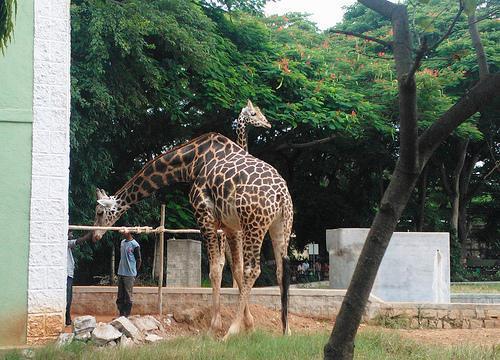How many giraffes are in the picture?
Give a very brief answer. 2. 